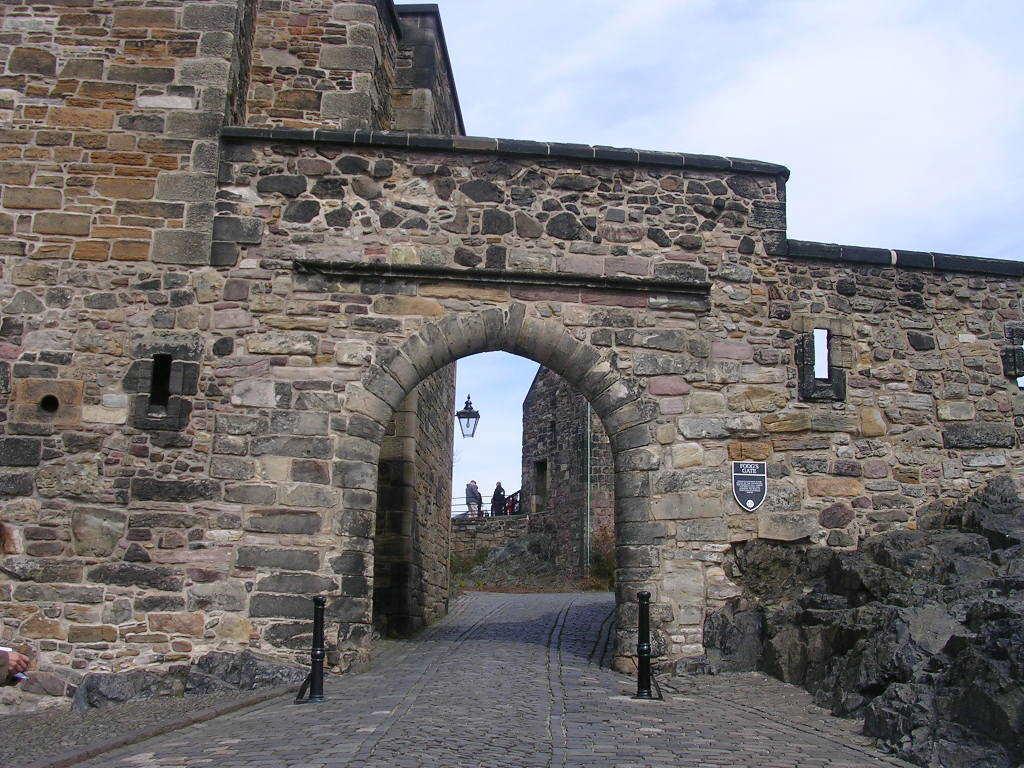Could you give a brief overview of what you see in this image? The picture consists of castle made of stone walls. In the foreground there are poles and board. In the center of the picture there is a light. Sky is cloudy. 